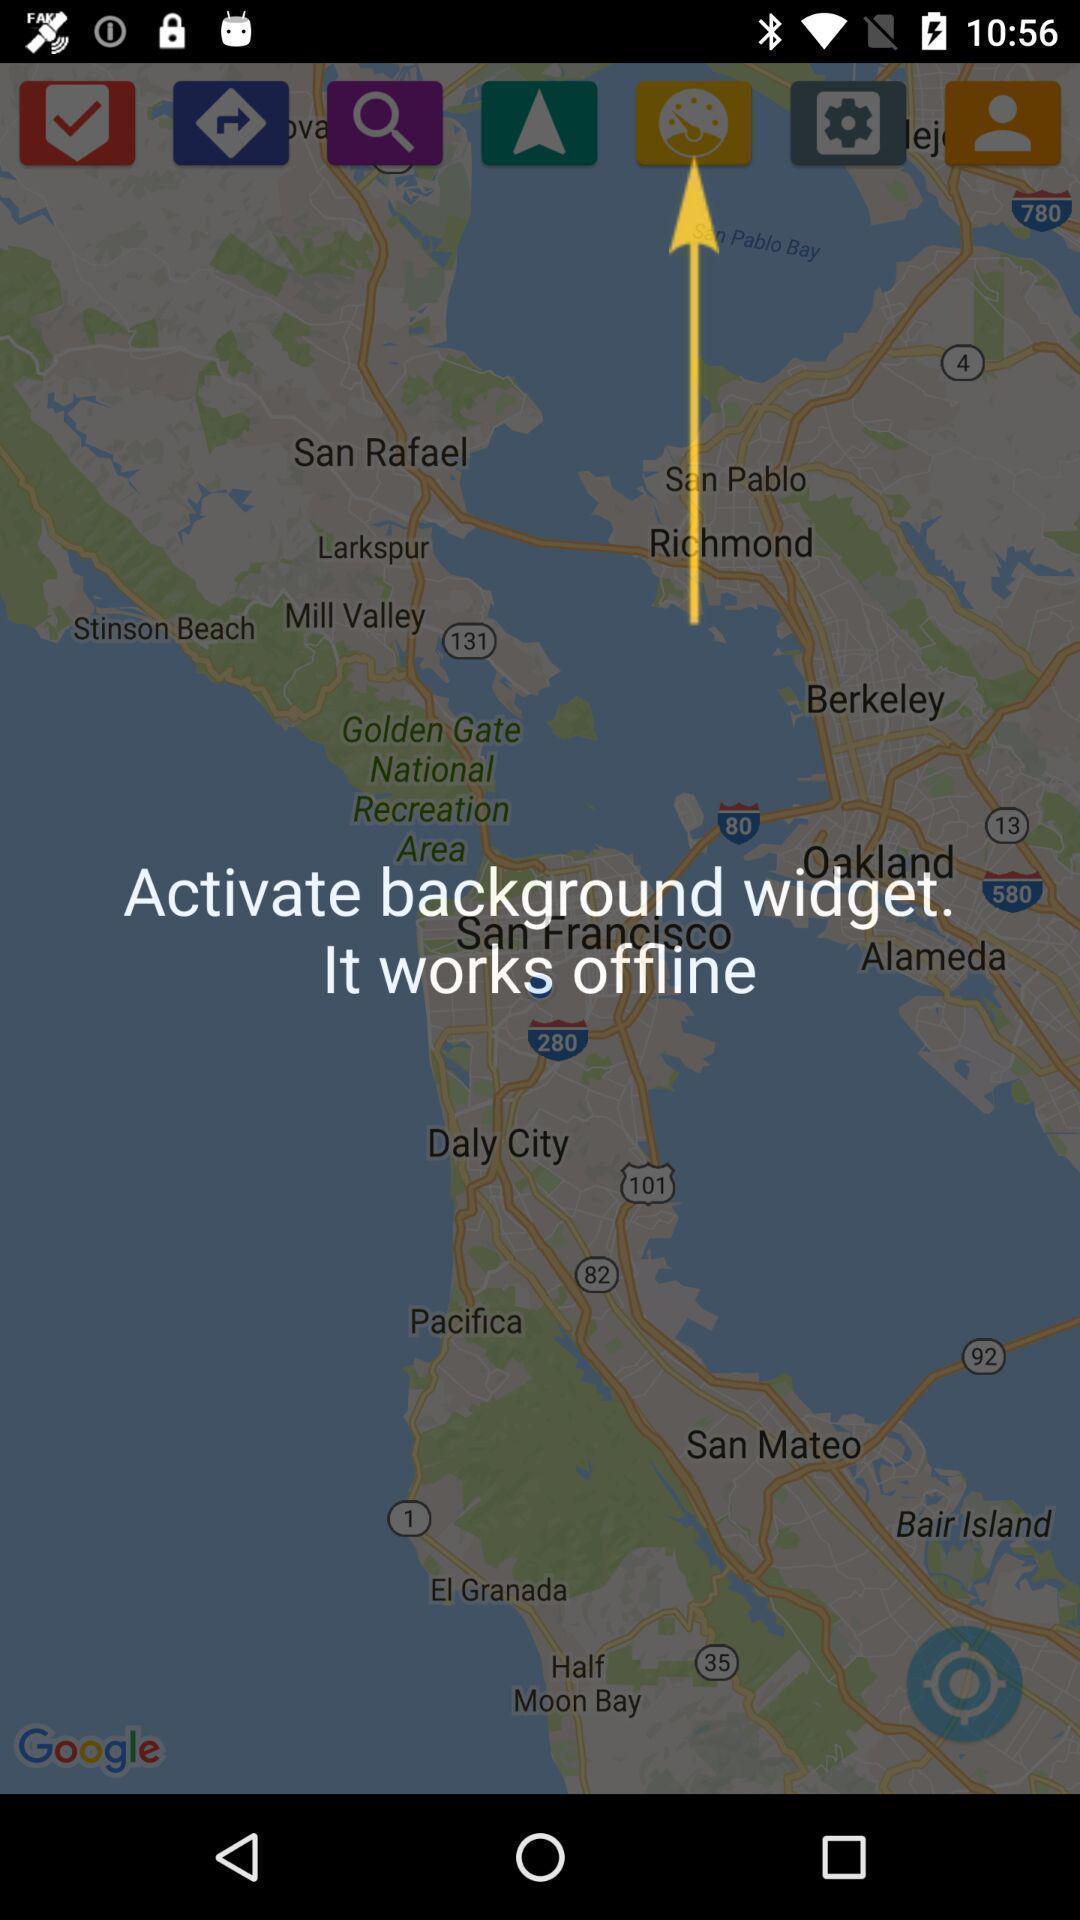What is the overall content of this screenshot? Pop-up showing the notification to activate widget. 